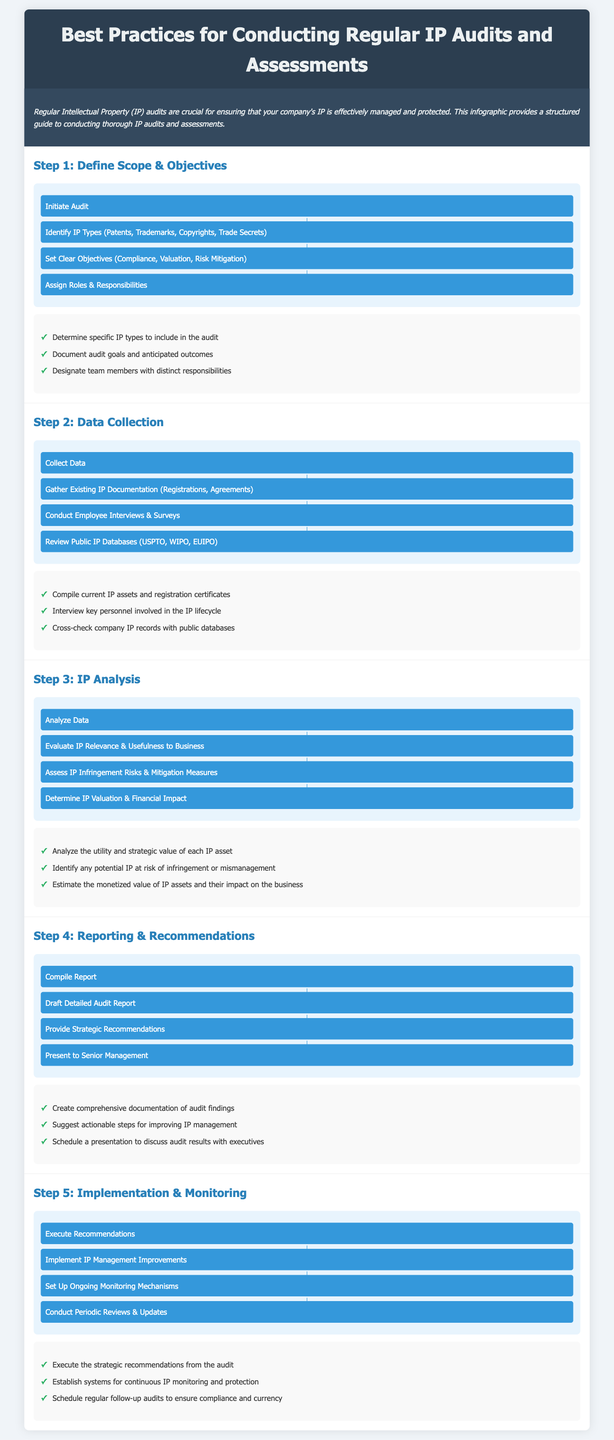What is the title of the infographic? The title appears at the top of the document and summarizes the main theme.
Answer: Best Practices for Conducting Regular IP Audits and Assessments What is the first step in the IP audit process? The first step is outlined in the initial section of the infographic.
Answer: Define Scope & Objectives How many types of IP are identified in the process? The document lists specific types of IP within the first step's flowchart.
Answer: Four What is one method of data collection mentioned? The document provides various data collection methods in the second step's flowchart.
Answer: Employee Interviews & Surveys What should the audit report include? The reporting step emphasizes a particular element that should be part of the report.
Answer: Audit findings In how many steps is the IP audit process divided? The infographic lays out a specific number of steps in the process.
Answer: Five What is the final action in the implementation stage? The last item in the flowchart for implementation specifies a required action.
Answer: Conduct Periodic Reviews & Updates What is the purpose of the flowcharts in the document? The flowcharts illustrate the procedural steps visually throughout the infographic.
Answer: To outline the audit process What kind of monitoring is suggested after implementation? The checklist under the last step emphasizes a particular focus for monitoring.
Answer: Ongoing Monitoring Mechanisms 